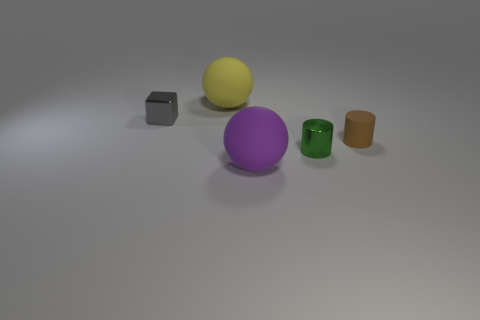What number of things are either tiny things in front of the small matte object or tiny gray shiny blocks?
Provide a short and direct response. 2. There is a large object that is behind the large matte object that is in front of the yellow matte object; what shape is it?
Your answer should be compact. Sphere. Is there another cylinder that has the same size as the green cylinder?
Offer a very short reply. Yes. Is the number of rubber balls greater than the number of tiny objects?
Offer a very short reply. No. Do the matte sphere on the left side of the purple rubber thing and the metal thing on the left side of the green cylinder have the same size?
Ensure brevity in your answer.  No. What number of rubber objects are right of the large yellow rubber thing and to the left of the tiny green cylinder?
Provide a succinct answer. 1. There is another big rubber thing that is the same shape as the large purple rubber thing; what is its color?
Your answer should be compact. Yellow. Is the number of small green metallic things less than the number of small red matte objects?
Provide a short and direct response. No. There is a yellow matte thing; does it have the same size as the rubber thing that is right of the purple object?
Give a very brief answer. No. The large matte thing that is behind the matte ball in front of the tiny green metal object is what color?
Make the answer very short. Yellow. 